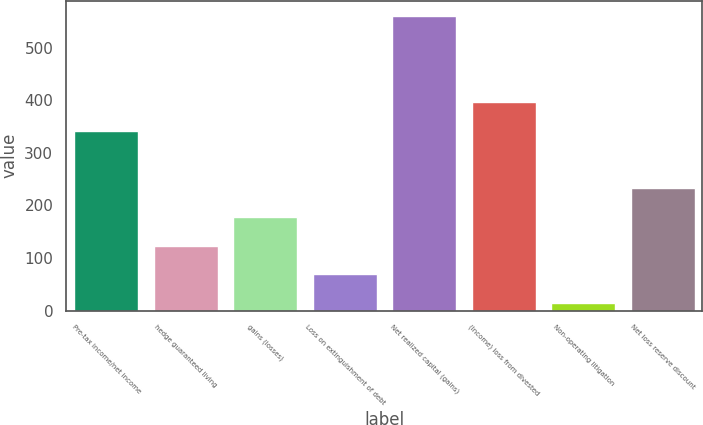Convert chart to OTSL. <chart><loc_0><loc_0><loc_500><loc_500><bar_chart><fcel>Pre-tax income/net income<fcel>hedge guaranteed living<fcel>gains (losses)<fcel>Loss on extinguishment of debt<fcel>Net realized capital (gains)<fcel>(Income) loss from divested<fcel>Non-operating litigation<fcel>Net loss reserve discount<nl><fcel>342.2<fcel>123.4<fcel>178.1<fcel>68.7<fcel>561<fcel>396.9<fcel>14<fcel>232.8<nl></chart> 